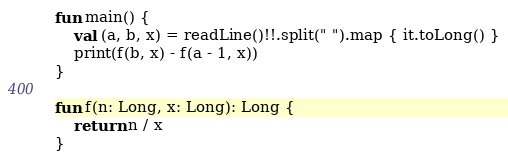<code> <loc_0><loc_0><loc_500><loc_500><_Kotlin_>fun main() {
    val (a, b, x) = readLine()!!.split(" ").map { it.toLong() }
    print(f(b, x) - f(a - 1, x))
}

fun f(n: Long, x: Long): Long {
    return n / x
}
</code> 